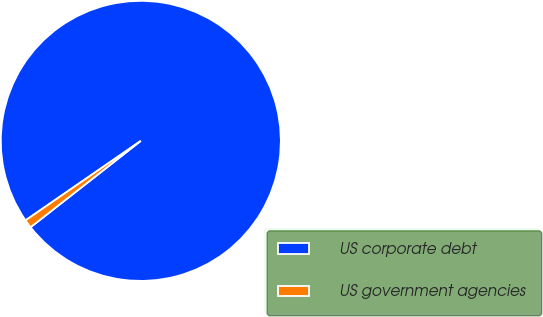Convert chart. <chart><loc_0><loc_0><loc_500><loc_500><pie_chart><fcel>US corporate debt<fcel>US government agencies<nl><fcel>99.03%<fcel>0.97%<nl></chart> 